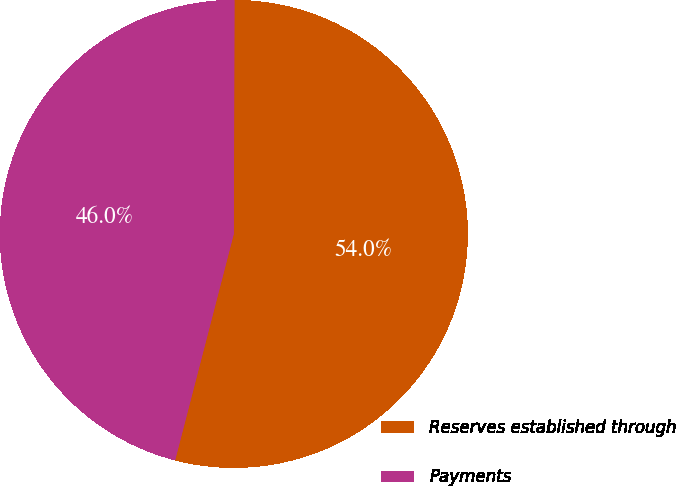Convert chart to OTSL. <chart><loc_0><loc_0><loc_500><loc_500><pie_chart><fcel>Reserves established through<fcel>Payments<nl><fcel>53.99%<fcel>46.01%<nl></chart> 